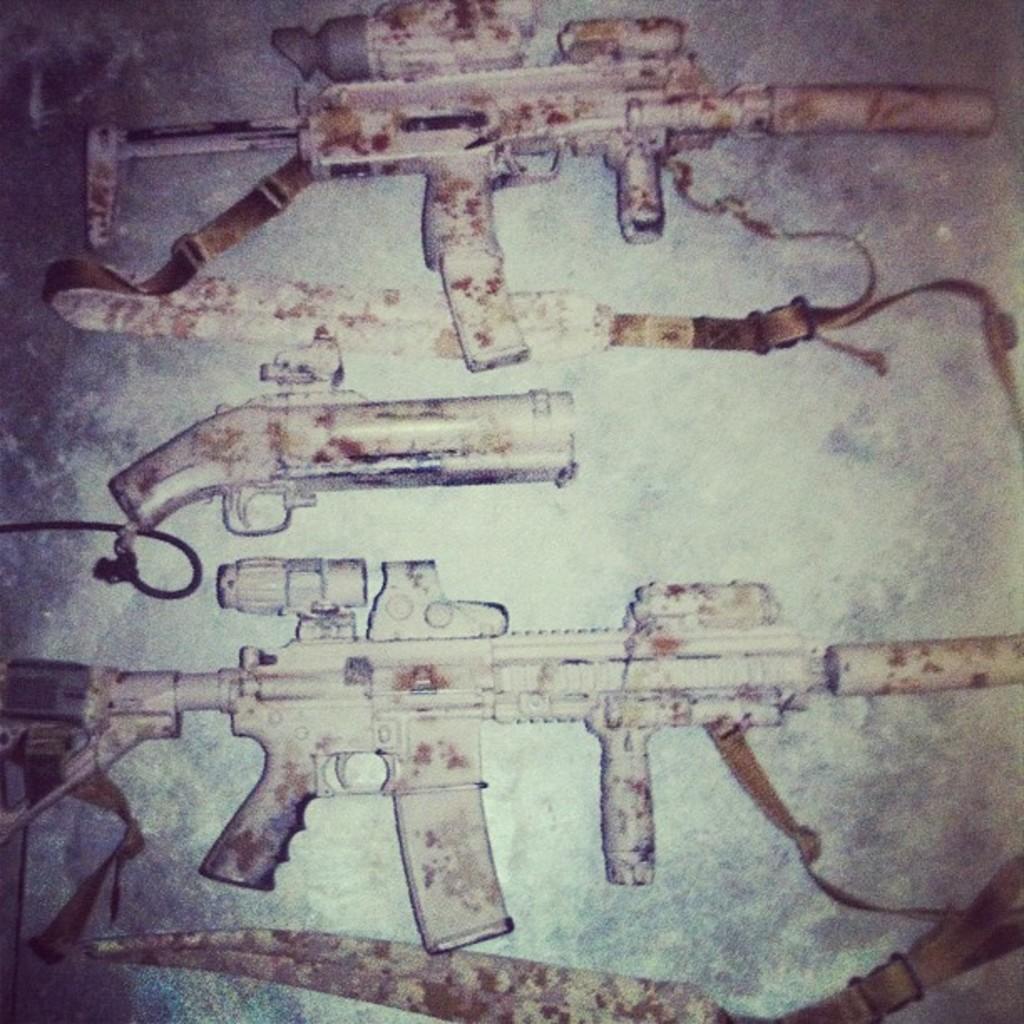Could you give a brief overview of what you see in this image? In the image there are few weapons kept on a surface and there are some white color patches on the weapons. 